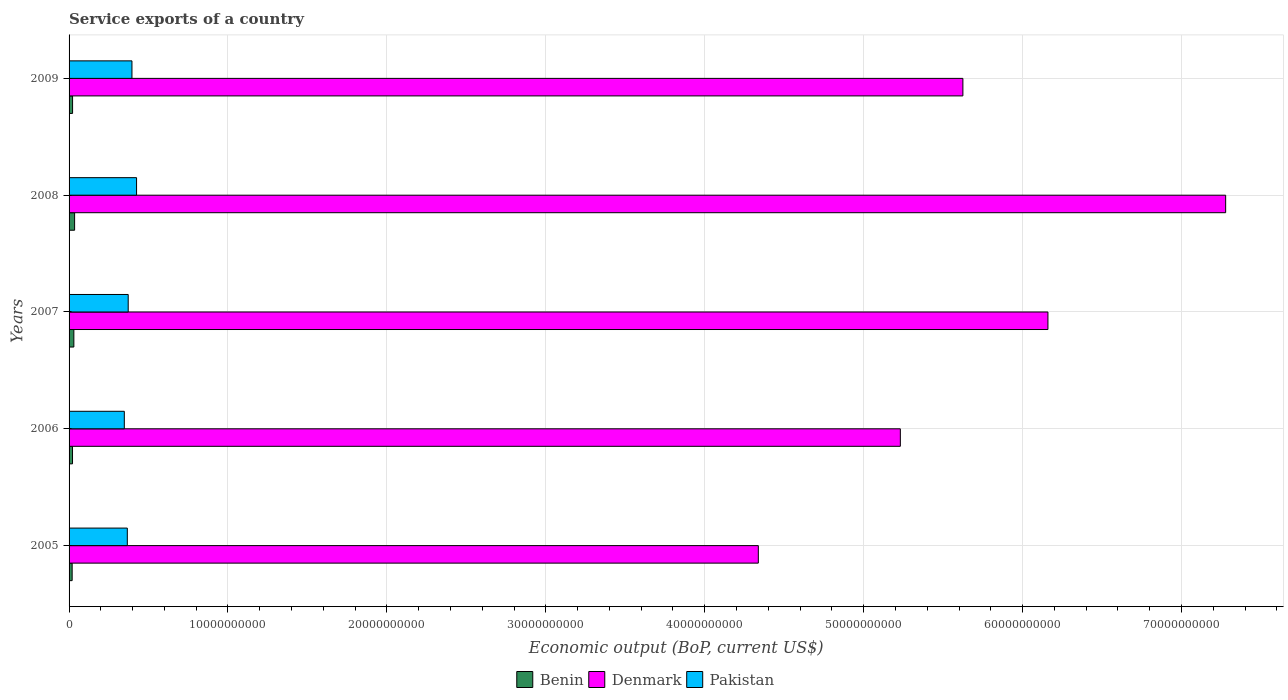How many different coloured bars are there?
Give a very brief answer. 3. Are the number of bars per tick equal to the number of legend labels?
Your answer should be compact. Yes. Are the number of bars on each tick of the Y-axis equal?
Your response must be concise. Yes. How many bars are there on the 1st tick from the top?
Make the answer very short. 3. How many bars are there on the 2nd tick from the bottom?
Your response must be concise. 3. What is the service exports in Benin in 2009?
Make the answer very short. 2.21e+08. Across all years, what is the maximum service exports in Benin?
Provide a short and direct response. 3.48e+08. Across all years, what is the minimum service exports in Denmark?
Make the answer very short. 4.34e+1. What is the total service exports in Denmark in the graph?
Your response must be concise. 2.86e+11. What is the difference between the service exports in Pakistan in 2005 and that in 2008?
Keep it short and to the point. -5.82e+08. What is the difference between the service exports in Denmark in 2008 and the service exports in Benin in 2007?
Offer a very short reply. 7.25e+1. What is the average service exports in Benin per year?
Your answer should be compact. 2.56e+08. In the year 2008, what is the difference between the service exports in Benin and service exports in Denmark?
Your answer should be compact. -7.24e+1. In how many years, is the service exports in Denmark greater than 40000000000 US$?
Give a very brief answer. 5. What is the ratio of the service exports in Benin in 2006 to that in 2007?
Keep it short and to the point. 0.72. Is the service exports in Benin in 2005 less than that in 2006?
Your response must be concise. Yes. What is the difference between the highest and the second highest service exports in Pakistan?
Offer a very short reply. 2.90e+08. What is the difference between the highest and the lowest service exports in Benin?
Your response must be concise. 1.54e+08. Is the sum of the service exports in Benin in 2006 and 2008 greater than the maximum service exports in Denmark across all years?
Provide a succinct answer. No. What does the 2nd bar from the top in 2005 represents?
Make the answer very short. Denmark. What does the 1st bar from the bottom in 2009 represents?
Your answer should be very brief. Benin. Is it the case that in every year, the sum of the service exports in Denmark and service exports in Pakistan is greater than the service exports in Benin?
Provide a succinct answer. Yes. Are all the bars in the graph horizontal?
Ensure brevity in your answer.  Yes. How many years are there in the graph?
Provide a short and direct response. 5. Are the values on the major ticks of X-axis written in scientific E-notation?
Offer a terse response. No. Does the graph contain any zero values?
Provide a short and direct response. No. Where does the legend appear in the graph?
Offer a terse response. Bottom center. What is the title of the graph?
Your answer should be compact. Service exports of a country. Does "Azerbaijan" appear as one of the legend labels in the graph?
Your answer should be compact. No. What is the label or title of the X-axis?
Give a very brief answer. Economic output (BoP, current US$). What is the label or title of the Y-axis?
Offer a very short reply. Years. What is the Economic output (BoP, current US$) of Benin in 2005?
Make the answer very short. 1.94e+08. What is the Economic output (BoP, current US$) of Denmark in 2005?
Ensure brevity in your answer.  4.34e+1. What is the Economic output (BoP, current US$) of Pakistan in 2005?
Your answer should be very brief. 3.66e+09. What is the Economic output (BoP, current US$) of Benin in 2006?
Ensure brevity in your answer.  2.17e+08. What is the Economic output (BoP, current US$) in Denmark in 2006?
Ensure brevity in your answer.  5.23e+1. What is the Economic output (BoP, current US$) of Pakistan in 2006?
Your answer should be very brief. 3.48e+09. What is the Economic output (BoP, current US$) in Benin in 2007?
Your answer should be very brief. 3.02e+08. What is the Economic output (BoP, current US$) in Denmark in 2007?
Your response must be concise. 6.16e+1. What is the Economic output (BoP, current US$) of Pakistan in 2007?
Offer a very short reply. 3.72e+09. What is the Economic output (BoP, current US$) in Benin in 2008?
Your response must be concise. 3.48e+08. What is the Economic output (BoP, current US$) of Denmark in 2008?
Your response must be concise. 7.28e+1. What is the Economic output (BoP, current US$) in Pakistan in 2008?
Make the answer very short. 4.25e+09. What is the Economic output (BoP, current US$) in Benin in 2009?
Your answer should be compact. 2.21e+08. What is the Economic output (BoP, current US$) of Denmark in 2009?
Make the answer very short. 5.62e+1. What is the Economic output (BoP, current US$) of Pakistan in 2009?
Offer a terse response. 3.96e+09. Across all years, what is the maximum Economic output (BoP, current US$) of Benin?
Your answer should be very brief. 3.48e+08. Across all years, what is the maximum Economic output (BoP, current US$) in Denmark?
Make the answer very short. 7.28e+1. Across all years, what is the maximum Economic output (BoP, current US$) in Pakistan?
Provide a short and direct response. 4.25e+09. Across all years, what is the minimum Economic output (BoP, current US$) of Benin?
Offer a terse response. 1.94e+08. Across all years, what is the minimum Economic output (BoP, current US$) of Denmark?
Offer a terse response. 4.34e+1. Across all years, what is the minimum Economic output (BoP, current US$) in Pakistan?
Offer a terse response. 3.48e+09. What is the total Economic output (BoP, current US$) of Benin in the graph?
Your response must be concise. 1.28e+09. What is the total Economic output (BoP, current US$) of Denmark in the graph?
Make the answer very short. 2.86e+11. What is the total Economic output (BoP, current US$) in Pakistan in the graph?
Your answer should be very brief. 1.91e+1. What is the difference between the Economic output (BoP, current US$) of Benin in 2005 and that in 2006?
Keep it short and to the point. -2.33e+07. What is the difference between the Economic output (BoP, current US$) in Denmark in 2005 and that in 2006?
Your answer should be compact. -8.94e+09. What is the difference between the Economic output (BoP, current US$) in Pakistan in 2005 and that in 2006?
Provide a short and direct response. 1.89e+08. What is the difference between the Economic output (BoP, current US$) in Benin in 2005 and that in 2007?
Offer a terse response. -1.08e+08. What is the difference between the Economic output (BoP, current US$) in Denmark in 2005 and that in 2007?
Your answer should be very brief. -1.82e+1. What is the difference between the Economic output (BoP, current US$) in Pakistan in 2005 and that in 2007?
Your response must be concise. -5.57e+07. What is the difference between the Economic output (BoP, current US$) of Benin in 2005 and that in 2008?
Your answer should be compact. -1.54e+08. What is the difference between the Economic output (BoP, current US$) in Denmark in 2005 and that in 2008?
Offer a very short reply. -2.94e+1. What is the difference between the Economic output (BoP, current US$) in Pakistan in 2005 and that in 2008?
Ensure brevity in your answer.  -5.82e+08. What is the difference between the Economic output (BoP, current US$) in Benin in 2005 and that in 2009?
Keep it short and to the point. -2.72e+07. What is the difference between the Economic output (BoP, current US$) of Denmark in 2005 and that in 2009?
Keep it short and to the point. -1.29e+1. What is the difference between the Economic output (BoP, current US$) of Pakistan in 2005 and that in 2009?
Provide a short and direct response. -2.92e+08. What is the difference between the Economic output (BoP, current US$) in Benin in 2006 and that in 2007?
Offer a very short reply. -8.45e+07. What is the difference between the Economic output (BoP, current US$) in Denmark in 2006 and that in 2007?
Ensure brevity in your answer.  -9.29e+09. What is the difference between the Economic output (BoP, current US$) in Pakistan in 2006 and that in 2007?
Ensure brevity in your answer.  -2.45e+08. What is the difference between the Economic output (BoP, current US$) of Benin in 2006 and that in 2008?
Give a very brief answer. -1.31e+08. What is the difference between the Economic output (BoP, current US$) in Denmark in 2006 and that in 2008?
Your response must be concise. -2.05e+1. What is the difference between the Economic output (BoP, current US$) of Pakistan in 2006 and that in 2008?
Keep it short and to the point. -7.71e+08. What is the difference between the Economic output (BoP, current US$) in Benin in 2006 and that in 2009?
Ensure brevity in your answer.  -3.87e+06. What is the difference between the Economic output (BoP, current US$) of Denmark in 2006 and that in 2009?
Offer a terse response. -3.94e+09. What is the difference between the Economic output (BoP, current US$) in Pakistan in 2006 and that in 2009?
Give a very brief answer. -4.81e+08. What is the difference between the Economic output (BoP, current US$) in Benin in 2007 and that in 2008?
Offer a terse response. -4.65e+07. What is the difference between the Economic output (BoP, current US$) of Denmark in 2007 and that in 2008?
Provide a short and direct response. -1.12e+1. What is the difference between the Economic output (BoP, current US$) of Pakistan in 2007 and that in 2008?
Offer a terse response. -5.26e+08. What is the difference between the Economic output (BoP, current US$) in Benin in 2007 and that in 2009?
Ensure brevity in your answer.  8.06e+07. What is the difference between the Economic output (BoP, current US$) in Denmark in 2007 and that in 2009?
Provide a succinct answer. 5.35e+09. What is the difference between the Economic output (BoP, current US$) in Pakistan in 2007 and that in 2009?
Your answer should be very brief. -2.36e+08. What is the difference between the Economic output (BoP, current US$) of Benin in 2008 and that in 2009?
Offer a very short reply. 1.27e+08. What is the difference between the Economic output (BoP, current US$) of Denmark in 2008 and that in 2009?
Provide a short and direct response. 1.65e+1. What is the difference between the Economic output (BoP, current US$) of Pakistan in 2008 and that in 2009?
Your answer should be very brief. 2.90e+08. What is the difference between the Economic output (BoP, current US$) of Benin in 2005 and the Economic output (BoP, current US$) of Denmark in 2006?
Keep it short and to the point. -5.21e+1. What is the difference between the Economic output (BoP, current US$) in Benin in 2005 and the Economic output (BoP, current US$) in Pakistan in 2006?
Give a very brief answer. -3.28e+09. What is the difference between the Economic output (BoP, current US$) in Denmark in 2005 and the Economic output (BoP, current US$) in Pakistan in 2006?
Provide a short and direct response. 3.99e+1. What is the difference between the Economic output (BoP, current US$) in Benin in 2005 and the Economic output (BoP, current US$) in Denmark in 2007?
Your answer should be very brief. -6.14e+1. What is the difference between the Economic output (BoP, current US$) in Benin in 2005 and the Economic output (BoP, current US$) in Pakistan in 2007?
Your response must be concise. -3.53e+09. What is the difference between the Economic output (BoP, current US$) of Denmark in 2005 and the Economic output (BoP, current US$) of Pakistan in 2007?
Your answer should be very brief. 3.97e+1. What is the difference between the Economic output (BoP, current US$) of Benin in 2005 and the Economic output (BoP, current US$) of Denmark in 2008?
Your answer should be very brief. -7.26e+1. What is the difference between the Economic output (BoP, current US$) of Benin in 2005 and the Economic output (BoP, current US$) of Pakistan in 2008?
Ensure brevity in your answer.  -4.05e+09. What is the difference between the Economic output (BoP, current US$) of Denmark in 2005 and the Economic output (BoP, current US$) of Pakistan in 2008?
Provide a succinct answer. 3.91e+1. What is the difference between the Economic output (BoP, current US$) of Benin in 2005 and the Economic output (BoP, current US$) of Denmark in 2009?
Make the answer very short. -5.60e+1. What is the difference between the Economic output (BoP, current US$) in Benin in 2005 and the Economic output (BoP, current US$) in Pakistan in 2009?
Give a very brief answer. -3.76e+09. What is the difference between the Economic output (BoP, current US$) of Denmark in 2005 and the Economic output (BoP, current US$) of Pakistan in 2009?
Your answer should be very brief. 3.94e+1. What is the difference between the Economic output (BoP, current US$) in Benin in 2006 and the Economic output (BoP, current US$) in Denmark in 2007?
Provide a succinct answer. -6.14e+1. What is the difference between the Economic output (BoP, current US$) of Benin in 2006 and the Economic output (BoP, current US$) of Pakistan in 2007?
Make the answer very short. -3.50e+09. What is the difference between the Economic output (BoP, current US$) of Denmark in 2006 and the Economic output (BoP, current US$) of Pakistan in 2007?
Your answer should be compact. 4.86e+1. What is the difference between the Economic output (BoP, current US$) of Benin in 2006 and the Economic output (BoP, current US$) of Denmark in 2008?
Provide a succinct answer. -7.26e+1. What is the difference between the Economic output (BoP, current US$) in Benin in 2006 and the Economic output (BoP, current US$) in Pakistan in 2008?
Make the answer very short. -4.03e+09. What is the difference between the Economic output (BoP, current US$) of Denmark in 2006 and the Economic output (BoP, current US$) of Pakistan in 2008?
Offer a terse response. 4.81e+1. What is the difference between the Economic output (BoP, current US$) of Benin in 2006 and the Economic output (BoP, current US$) of Denmark in 2009?
Give a very brief answer. -5.60e+1. What is the difference between the Economic output (BoP, current US$) of Benin in 2006 and the Economic output (BoP, current US$) of Pakistan in 2009?
Your response must be concise. -3.74e+09. What is the difference between the Economic output (BoP, current US$) in Denmark in 2006 and the Economic output (BoP, current US$) in Pakistan in 2009?
Your answer should be very brief. 4.84e+1. What is the difference between the Economic output (BoP, current US$) in Benin in 2007 and the Economic output (BoP, current US$) in Denmark in 2008?
Give a very brief answer. -7.25e+1. What is the difference between the Economic output (BoP, current US$) of Benin in 2007 and the Economic output (BoP, current US$) of Pakistan in 2008?
Provide a succinct answer. -3.95e+09. What is the difference between the Economic output (BoP, current US$) of Denmark in 2007 and the Economic output (BoP, current US$) of Pakistan in 2008?
Your answer should be very brief. 5.73e+1. What is the difference between the Economic output (BoP, current US$) of Benin in 2007 and the Economic output (BoP, current US$) of Denmark in 2009?
Offer a terse response. -5.59e+1. What is the difference between the Economic output (BoP, current US$) of Benin in 2007 and the Economic output (BoP, current US$) of Pakistan in 2009?
Offer a very short reply. -3.66e+09. What is the difference between the Economic output (BoP, current US$) of Denmark in 2007 and the Economic output (BoP, current US$) of Pakistan in 2009?
Provide a short and direct response. 5.76e+1. What is the difference between the Economic output (BoP, current US$) in Benin in 2008 and the Economic output (BoP, current US$) in Denmark in 2009?
Your answer should be compact. -5.59e+1. What is the difference between the Economic output (BoP, current US$) of Benin in 2008 and the Economic output (BoP, current US$) of Pakistan in 2009?
Provide a short and direct response. -3.61e+09. What is the difference between the Economic output (BoP, current US$) of Denmark in 2008 and the Economic output (BoP, current US$) of Pakistan in 2009?
Make the answer very short. 6.88e+1. What is the average Economic output (BoP, current US$) in Benin per year?
Offer a terse response. 2.56e+08. What is the average Economic output (BoP, current US$) of Denmark per year?
Keep it short and to the point. 5.73e+1. What is the average Economic output (BoP, current US$) in Pakistan per year?
Provide a short and direct response. 3.81e+09. In the year 2005, what is the difference between the Economic output (BoP, current US$) in Benin and Economic output (BoP, current US$) in Denmark?
Offer a very short reply. -4.32e+1. In the year 2005, what is the difference between the Economic output (BoP, current US$) of Benin and Economic output (BoP, current US$) of Pakistan?
Your answer should be compact. -3.47e+09. In the year 2005, what is the difference between the Economic output (BoP, current US$) of Denmark and Economic output (BoP, current US$) of Pakistan?
Your response must be concise. 3.97e+1. In the year 2006, what is the difference between the Economic output (BoP, current US$) of Benin and Economic output (BoP, current US$) of Denmark?
Provide a short and direct response. -5.21e+1. In the year 2006, what is the difference between the Economic output (BoP, current US$) in Benin and Economic output (BoP, current US$) in Pakistan?
Provide a succinct answer. -3.26e+09. In the year 2006, what is the difference between the Economic output (BoP, current US$) in Denmark and Economic output (BoP, current US$) in Pakistan?
Keep it short and to the point. 4.88e+1. In the year 2007, what is the difference between the Economic output (BoP, current US$) in Benin and Economic output (BoP, current US$) in Denmark?
Your answer should be compact. -6.13e+1. In the year 2007, what is the difference between the Economic output (BoP, current US$) in Benin and Economic output (BoP, current US$) in Pakistan?
Your answer should be very brief. -3.42e+09. In the year 2007, what is the difference between the Economic output (BoP, current US$) in Denmark and Economic output (BoP, current US$) in Pakistan?
Your response must be concise. 5.79e+1. In the year 2008, what is the difference between the Economic output (BoP, current US$) of Benin and Economic output (BoP, current US$) of Denmark?
Offer a terse response. -7.24e+1. In the year 2008, what is the difference between the Economic output (BoP, current US$) of Benin and Economic output (BoP, current US$) of Pakistan?
Your answer should be compact. -3.90e+09. In the year 2008, what is the difference between the Economic output (BoP, current US$) in Denmark and Economic output (BoP, current US$) in Pakistan?
Ensure brevity in your answer.  6.85e+1. In the year 2009, what is the difference between the Economic output (BoP, current US$) of Benin and Economic output (BoP, current US$) of Denmark?
Provide a short and direct response. -5.60e+1. In the year 2009, what is the difference between the Economic output (BoP, current US$) in Benin and Economic output (BoP, current US$) in Pakistan?
Your response must be concise. -3.74e+09. In the year 2009, what is the difference between the Economic output (BoP, current US$) in Denmark and Economic output (BoP, current US$) in Pakistan?
Give a very brief answer. 5.23e+1. What is the ratio of the Economic output (BoP, current US$) of Benin in 2005 to that in 2006?
Keep it short and to the point. 0.89. What is the ratio of the Economic output (BoP, current US$) in Denmark in 2005 to that in 2006?
Give a very brief answer. 0.83. What is the ratio of the Economic output (BoP, current US$) in Pakistan in 2005 to that in 2006?
Offer a terse response. 1.05. What is the ratio of the Economic output (BoP, current US$) of Benin in 2005 to that in 2007?
Offer a terse response. 0.64. What is the ratio of the Economic output (BoP, current US$) of Denmark in 2005 to that in 2007?
Make the answer very short. 0.7. What is the ratio of the Economic output (BoP, current US$) in Pakistan in 2005 to that in 2007?
Offer a very short reply. 0.98. What is the ratio of the Economic output (BoP, current US$) of Benin in 2005 to that in 2008?
Your answer should be very brief. 0.56. What is the ratio of the Economic output (BoP, current US$) in Denmark in 2005 to that in 2008?
Your answer should be compact. 0.6. What is the ratio of the Economic output (BoP, current US$) of Pakistan in 2005 to that in 2008?
Give a very brief answer. 0.86. What is the ratio of the Economic output (BoP, current US$) in Benin in 2005 to that in 2009?
Provide a succinct answer. 0.88. What is the ratio of the Economic output (BoP, current US$) in Denmark in 2005 to that in 2009?
Provide a succinct answer. 0.77. What is the ratio of the Economic output (BoP, current US$) of Pakistan in 2005 to that in 2009?
Your answer should be very brief. 0.93. What is the ratio of the Economic output (BoP, current US$) of Benin in 2006 to that in 2007?
Offer a terse response. 0.72. What is the ratio of the Economic output (BoP, current US$) of Denmark in 2006 to that in 2007?
Your answer should be very brief. 0.85. What is the ratio of the Economic output (BoP, current US$) in Pakistan in 2006 to that in 2007?
Make the answer very short. 0.93. What is the ratio of the Economic output (BoP, current US$) of Benin in 2006 to that in 2008?
Ensure brevity in your answer.  0.62. What is the ratio of the Economic output (BoP, current US$) of Denmark in 2006 to that in 2008?
Provide a short and direct response. 0.72. What is the ratio of the Economic output (BoP, current US$) of Pakistan in 2006 to that in 2008?
Offer a terse response. 0.82. What is the ratio of the Economic output (BoP, current US$) of Benin in 2006 to that in 2009?
Your response must be concise. 0.98. What is the ratio of the Economic output (BoP, current US$) of Denmark in 2006 to that in 2009?
Your answer should be compact. 0.93. What is the ratio of the Economic output (BoP, current US$) of Pakistan in 2006 to that in 2009?
Provide a succinct answer. 0.88. What is the ratio of the Economic output (BoP, current US$) in Benin in 2007 to that in 2008?
Your response must be concise. 0.87. What is the ratio of the Economic output (BoP, current US$) of Denmark in 2007 to that in 2008?
Offer a very short reply. 0.85. What is the ratio of the Economic output (BoP, current US$) of Pakistan in 2007 to that in 2008?
Your answer should be compact. 0.88. What is the ratio of the Economic output (BoP, current US$) in Benin in 2007 to that in 2009?
Provide a short and direct response. 1.36. What is the ratio of the Economic output (BoP, current US$) in Denmark in 2007 to that in 2009?
Your answer should be very brief. 1.1. What is the ratio of the Economic output (BoP, current US$) of Pakistan in 2007 to that in 2009?
Offer a very short reply. 0.94. What is the ratio of the Economic output (BoP, current US$) in Benin in 2008 to that in 2009?
Your response must be concise. 1.58. What is the ratio of the Economic output (BoP, current US$) in Denmark in 2008 to that in 2009?
Give a very brief answer. 1.29. What is the ratio of the Economic output (BoP, current US$) in Pakistan in 2008 to that in 2009?
Your answer should be compact. 1.07. What is the difference between the highest and the second highest Economic output (BoP, current US$) in Benin?
Make the answer very short. 4.65e+07. What is the difference between the highest and the second highest Economic output (BoP, current US$) of Denmark?
Your response must be concise. 1.12e+1. What is the difference between the highest and the second highest Economic output (BoP, current US$) of Pakistan?
Your answer should be compact. 2.90e+08. What is the difference between the highest and the lowest Economic output (BoP, current US$) in Benin?
Keep it short and to the point. 1.54e+08. What is the difference between the highest and the lowest Economic output (BoP, current US$) in Denmark?
Ensure brevity in your answer.  2.94e+1. What is the difference between the highest and the lowest Economic output (BoP, current US$) of Pakistan?
Offer a terse response. 7.71e+08. 